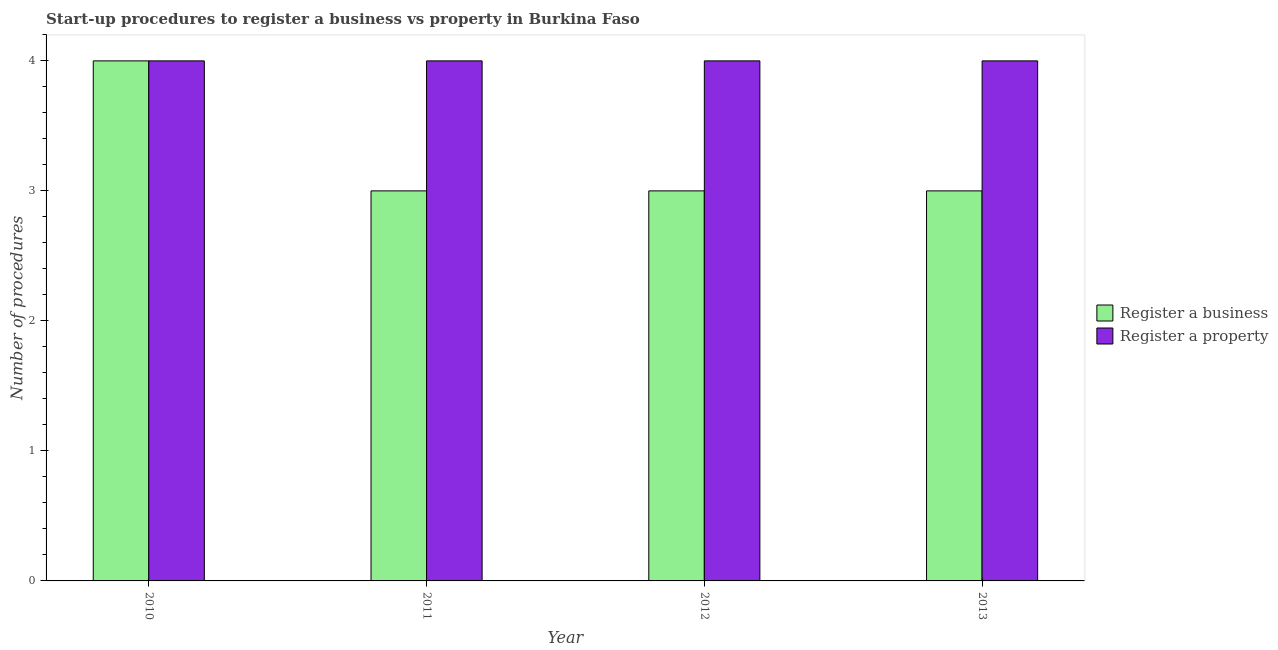How many groups of bars are there?
Make the answer very short. 4. Are the number of bars per tick equal to the number of legend labels?
Keep it short and to the point. Yes. Are the number of bars on each tick of the X-axis equal?
Offer a terse response. Yes. How many bars are there on the 1st tick from the left?
Offer a terse response. 2. How many bars are there on the 3rd tick from the right?
Provide a short and direct response. 2. What is the number of procedures to register a business in 2012?
Offer a very short reply. 3. Across all years, what is the maximum number of procedures to register a business?
Your response must be concise. 4. Across all years, what is the minimum number of procedures to register a property?
Make the answer very short. 4. In which year was the number of procedures to register a property maximum?
Give a very brief answer. 2010. What is the total number of procedures to register a business in the graph?
Provide a succinct answer. 13. What is the difference between the number of procedures to register a property in 2011 and that in 2013?
Ensure brevity in your answer.  0. What is the difference between the number of procedures to register a business in 2011 and the number of procedures to register a property in 2010?
Give a very brief answer. -1. What is the average number of procedures to register a business per year?
Make the answer very short. 3.25. In how many years, is the number of procedures to register a property greater than 3.6?
Give a very brief answer. 4. What is the difference between the highest and the lowest number of procedures to register a business?
Ensure brevity in your answer.  1. Is the sum of the number of procedures to register a business in 2010 and 2013 greater than the maximum number of procedures to register a property across all years?
Your answer should be compact. Yes. What does the 2nd bar from the left in 2010 represents?
Provide a succinct answer. Register a property. What does the 2nd bar from the right in 2013 represents?
Provide a succinct answer. Register a business. How many bars are there?
Ensure brevity in your answer.  8. What is the difference between two consecutive major ticks on the Y-axis?
Keep it short and to the point. 1. Are the values on the major ticks of Y-axis written in scientific E-notation?
Your answer should be compact. No. Does the graph contain any zero values?
Your answer should be compact. No. Where does the legend appear in the graph?
Your response must be concise. Center right. What is the title of the graph?
Ensure brevity in your answer.  Start-up procedures to register a business vs property in Burkina Faso. What is the label or title of the X-axis?
Your answer should be very brief. Year. What is the label or title of the Y-axis?
Provide a succinct answer. Number of procedures. What is the Number of procedures in Register a business in 2010?
Make the answer very short. 4. What is the Number of procedures in Register a business in 2011?
Give a very brief answer. 3. What is the Number of procedures of Register a property in 2011?
Give a very brief answer. 4. What is the Number of procedures in Register a property in 2012?
Provide a short and direct response. 4. What is the Number of procedures of Register a property in 2013?
Ensure brevity in your answer.  4. Across all years, what is the minimum Number of procedures in Register a business?
Keep it short and to the point. 3. What is the difference between the Number of procedures of Register a business in 2010 and that in 2011?
Your response must be concise. 1. What is the difference between the Number of procedures in Register a business in 2010 and that in 2012?
Your response must be concise. 1. What is the difference between the Number of procedures of Register a business in 2010 and that in 2013?
Make the answer very short. 1. What is the difference between the Number of procedures in Register a property in 2010 and that in 2013?
Offer a terse response. 0. What is the difference between the Number of procedures of Register a property in 2011 and that in 2012?
Your response must be concise. 0. What is the difference between the Number of procedures of Register a business in 2011 and that in 2013?
Your answer should be very brief. 0. What is the difference between the Number of procedures of Register a business in 2012 and that in 2013?
Offer a very short reply. 0. What is the difference between the Number of procedures of Register a business in 2010 and the Number of procedures of Register a property in 2012?
Ensure brevity in your answer.  0. What is the difference between the Number of procedures in Register a business in 2011 and the Number of procedures in Register a property in 2013?
Give a very brief answer. -1. What is the average Number of procedures of Register a business per year?
Provide a succinct answer. 3.25. What is the average Number of procedures in Register a property per year?
Provide a succinct answer. 4. In the year 2010, what is the difference between the Number of procedures of Register a business and Number of procedures of Register a property?
Keep it short and to the point. 0. In the year 2011, what is the difference between the Number of procedures of Register a business and Number of procedures of Register a property?
Provide a succinct answer. -1. In the year 2013, what is the difference between the Number of procedures in Register a business and Number of procedures in Register a property?
Keep it short and to the point. -1. What is the ratio of the Number of procedures in Register a business in 2010 to that in 2011?
Keep it short and to the point. 1.33. What is the ratio of the Number of procedures in Register a property in 2010 to that in 2011?
Your answer should be compact. 1. What is the ratio of the Number of procedures of Register a property in 2010 to that in 2012?
Offer a terse response. 1. What is the ratio of the Number of procedures of Register a business in 2010 to that in 2013?
Provide a succinct answer. 1.33. What is the ratio of the Number of procedures in Register a property in 2010 to that in 2013?
Offer a terse response. 1. What is the ratio of the Number of procedures in Register a business in 2011 to that in 2012?
Offer a very short reply. 1. What is the ratio of the Number of procedures of Register a property in 2011 to that in 2013?
Your answer should be compact. 1. What is the ratio of the Number of procedures in Register a business in 2012 to that in 2013?
Offer a terse response. 1. What is the ratio of the Number of procedures of Register a property in 2012 to that in 2013?
Offer a very short reply. 1. What is the difference between the highest and the lowest Number of procedures of Register a property?
Keep it short and to the point. 0. 